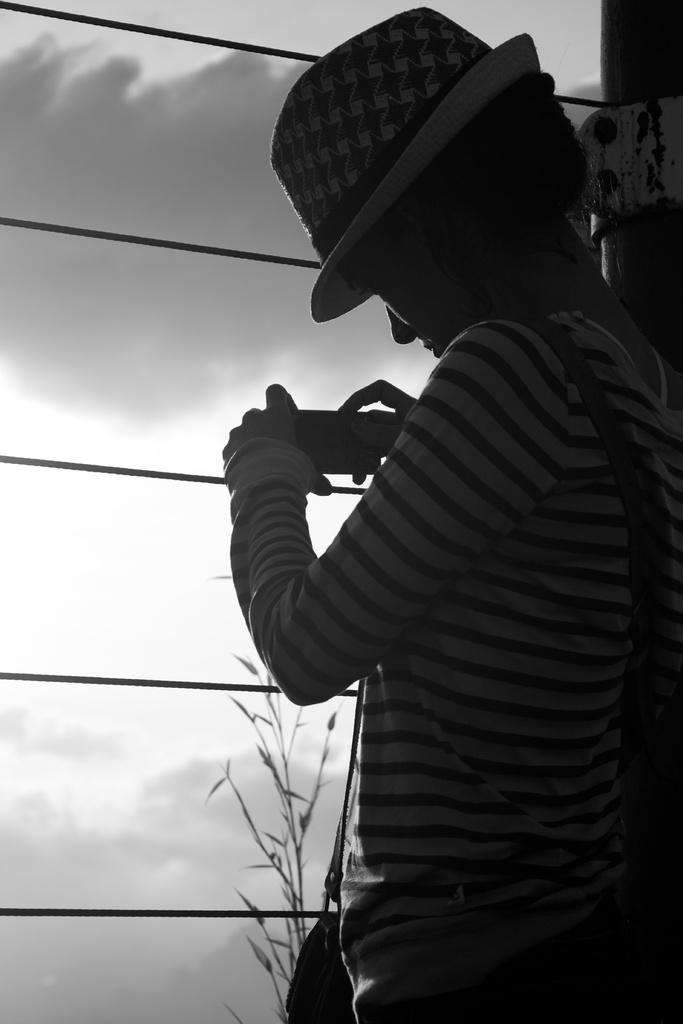What is the main subject of the image? There is a person standing in the image. Can you describe the person's attire? The person is wearing a hat. What is the person holding in the image? The person is holding an object. Are there any other people in the image? Yes, there is a girl in the image. What else can be seen in the image? There is a plant in the image. What is the color scheme of the image? The image is black and white. What type of dust can be seen on the hat of the beggar in the image? There is no beggar present in the image, and therefore no dust on a hat can be observed. Who is the owner of the plant in the image? The image does not provide information about the ownership of the plant, so it cannot be determined. 